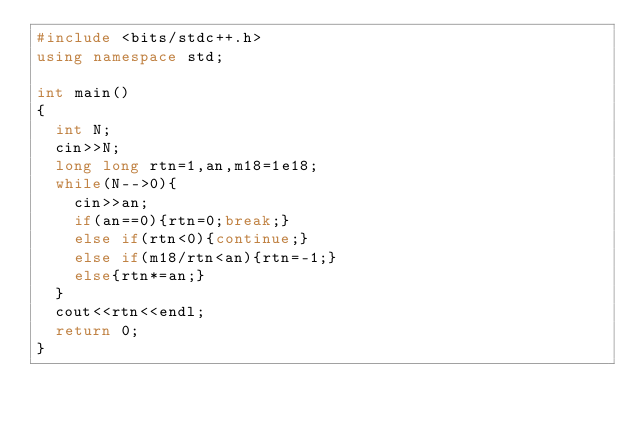<code> <loc_0><loc_0><loc_500><loc_500><_C++_>#include <bits/stdc++.h>
using namespace std;

int main()
{
  int N;
  cin>>N;
  long long rtn=1,an,m18=1e18;
  while(N-->0){
    cin>>an;
    if(an==0){rtn=0;break;}
    else if(rtn<0){continue;}
    else if(m18/rtn<an){rtn=-1;}
    else{rtn*=an;}
  }
  cout<<rtn<<endl;
  return 0;
}</code> 